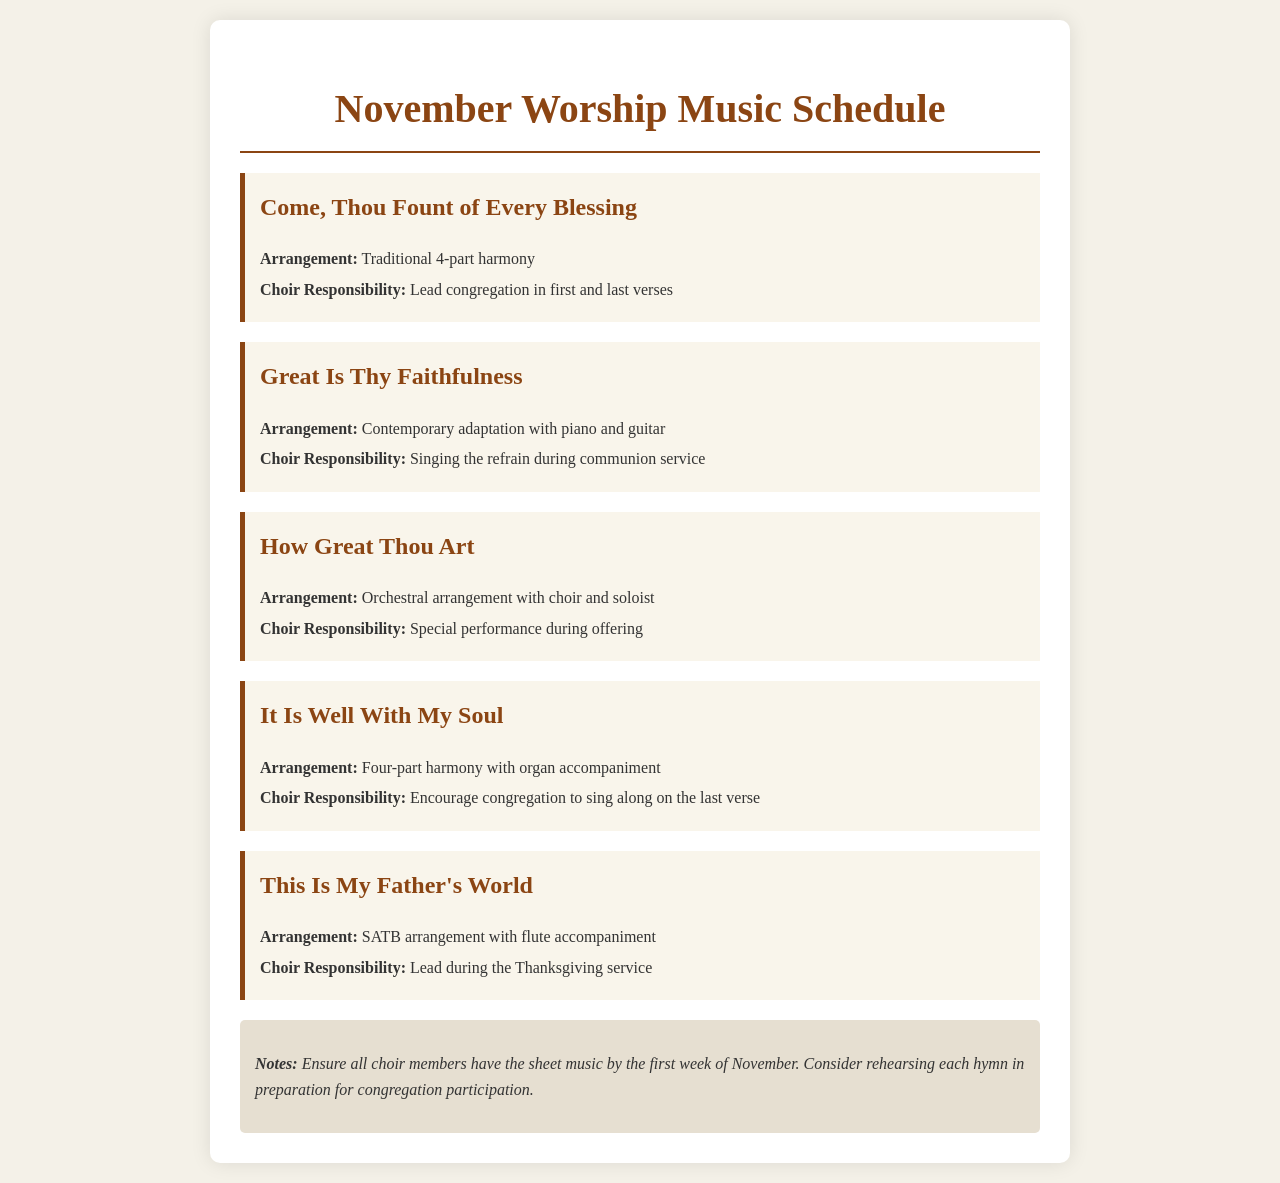What is the first hymn listed? The first hymn in the schedule is "Come, Thou Fount of Every Blessing."
Answer: Come, Thou Fount of Every Blessing What is the arrangement of "Great Is Thy Faithfulness"? The arrangement of "Great Is Thy Faithfulness" is described as a contemporary adaptation with piano and guitar.
Answer: Contemporary adaptation with piano and guitar What is the choir's responsibility for "How Great Thou Art"? The choir's responsibility for "How Great Thou Art" is a special performance during the offering.
Answer: Special performance during offering How many hymns are listed in the schedule? The schedule includes five hymns in total.
Answer: Five What accompaniment is used in "It Is Well With My Soul"? The accompaniment used in "It Is Well With My Soul" is an organ.
Answer: Organ accompaniment What special event is "This Is My Father's World" performed during? "This Is My Father's World" is performed during the Thanksgiving service.
Answer: Thanksgiving service What does the notes section mention about the choir members? The notes section mentions that all choir members should have the sheet music by the first week of November.
Answer: Sheet music by the first week of November What is the color of the hymn titles? The hymn titles are colored in a shade of brown (#8b4513).
Answer: Brown 